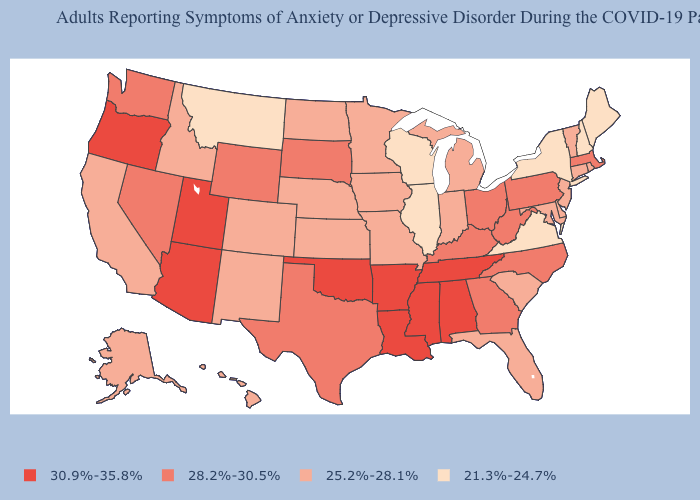Does Washington have the same value as Mississippi?
Short answer required. No. What is the lowest value in states that border Connecticut?
Concise answer only. 21.3%-24.7%. What is the value of Virginia?
Write a very short answer. 21.3%-24.7%. What is the value of North Carolina?
Answer briefly. 28.2%-30.5%. Among the states that border Michigan , does Wisconsin have the lowest value?
Answer briefly. Yes. Name the states that have a value in the range 25.2%-28.1%?
Answer briefly. Alaska, California, Colorado, Connecticut, Delaware, Florida, Hawaii, Idaho, Indiana, Iowa, Kansas, Maryland, Michigan, Minnesota, Missouri, Nebraska, New Jersey, New Mexico, North Dakota, Rhode Island, South Carolina, Vermont. Does Wisconsin have a lower value than Ohio?
Answer briefly. Yes. Which states have the lowest value in the USA?
Be succinct. Illinois, Maine, Montana, New Hampshire, New York, Virginia, Wisconsin. Does Louisiana have a higher value than Oklahoma?
Write a very short answer. No. Does Montana have a higher value than Maryland?
Answer briefly. No. Which states have the lowest value in the USA?
Answer briefly. Illinois, Maine, Montana, New Hampshire, New York, Virginia, Wisconsin. What is the value of Arizona?
Short answer required. 30.9%-35.8%. Does the map have missing data?
Quick response, please. No. Name the states that have a value in the range 21.3%-24.7%?
Answer briefly. Illinois, Maine, Montana, New Hampshire, New York, Virginia, Wisconsin. Which states have the lowest value in the USA?
Short answer required. Illinois, Maine, Montana, New Hampshire, New York, Virginia, Wisconsin. 